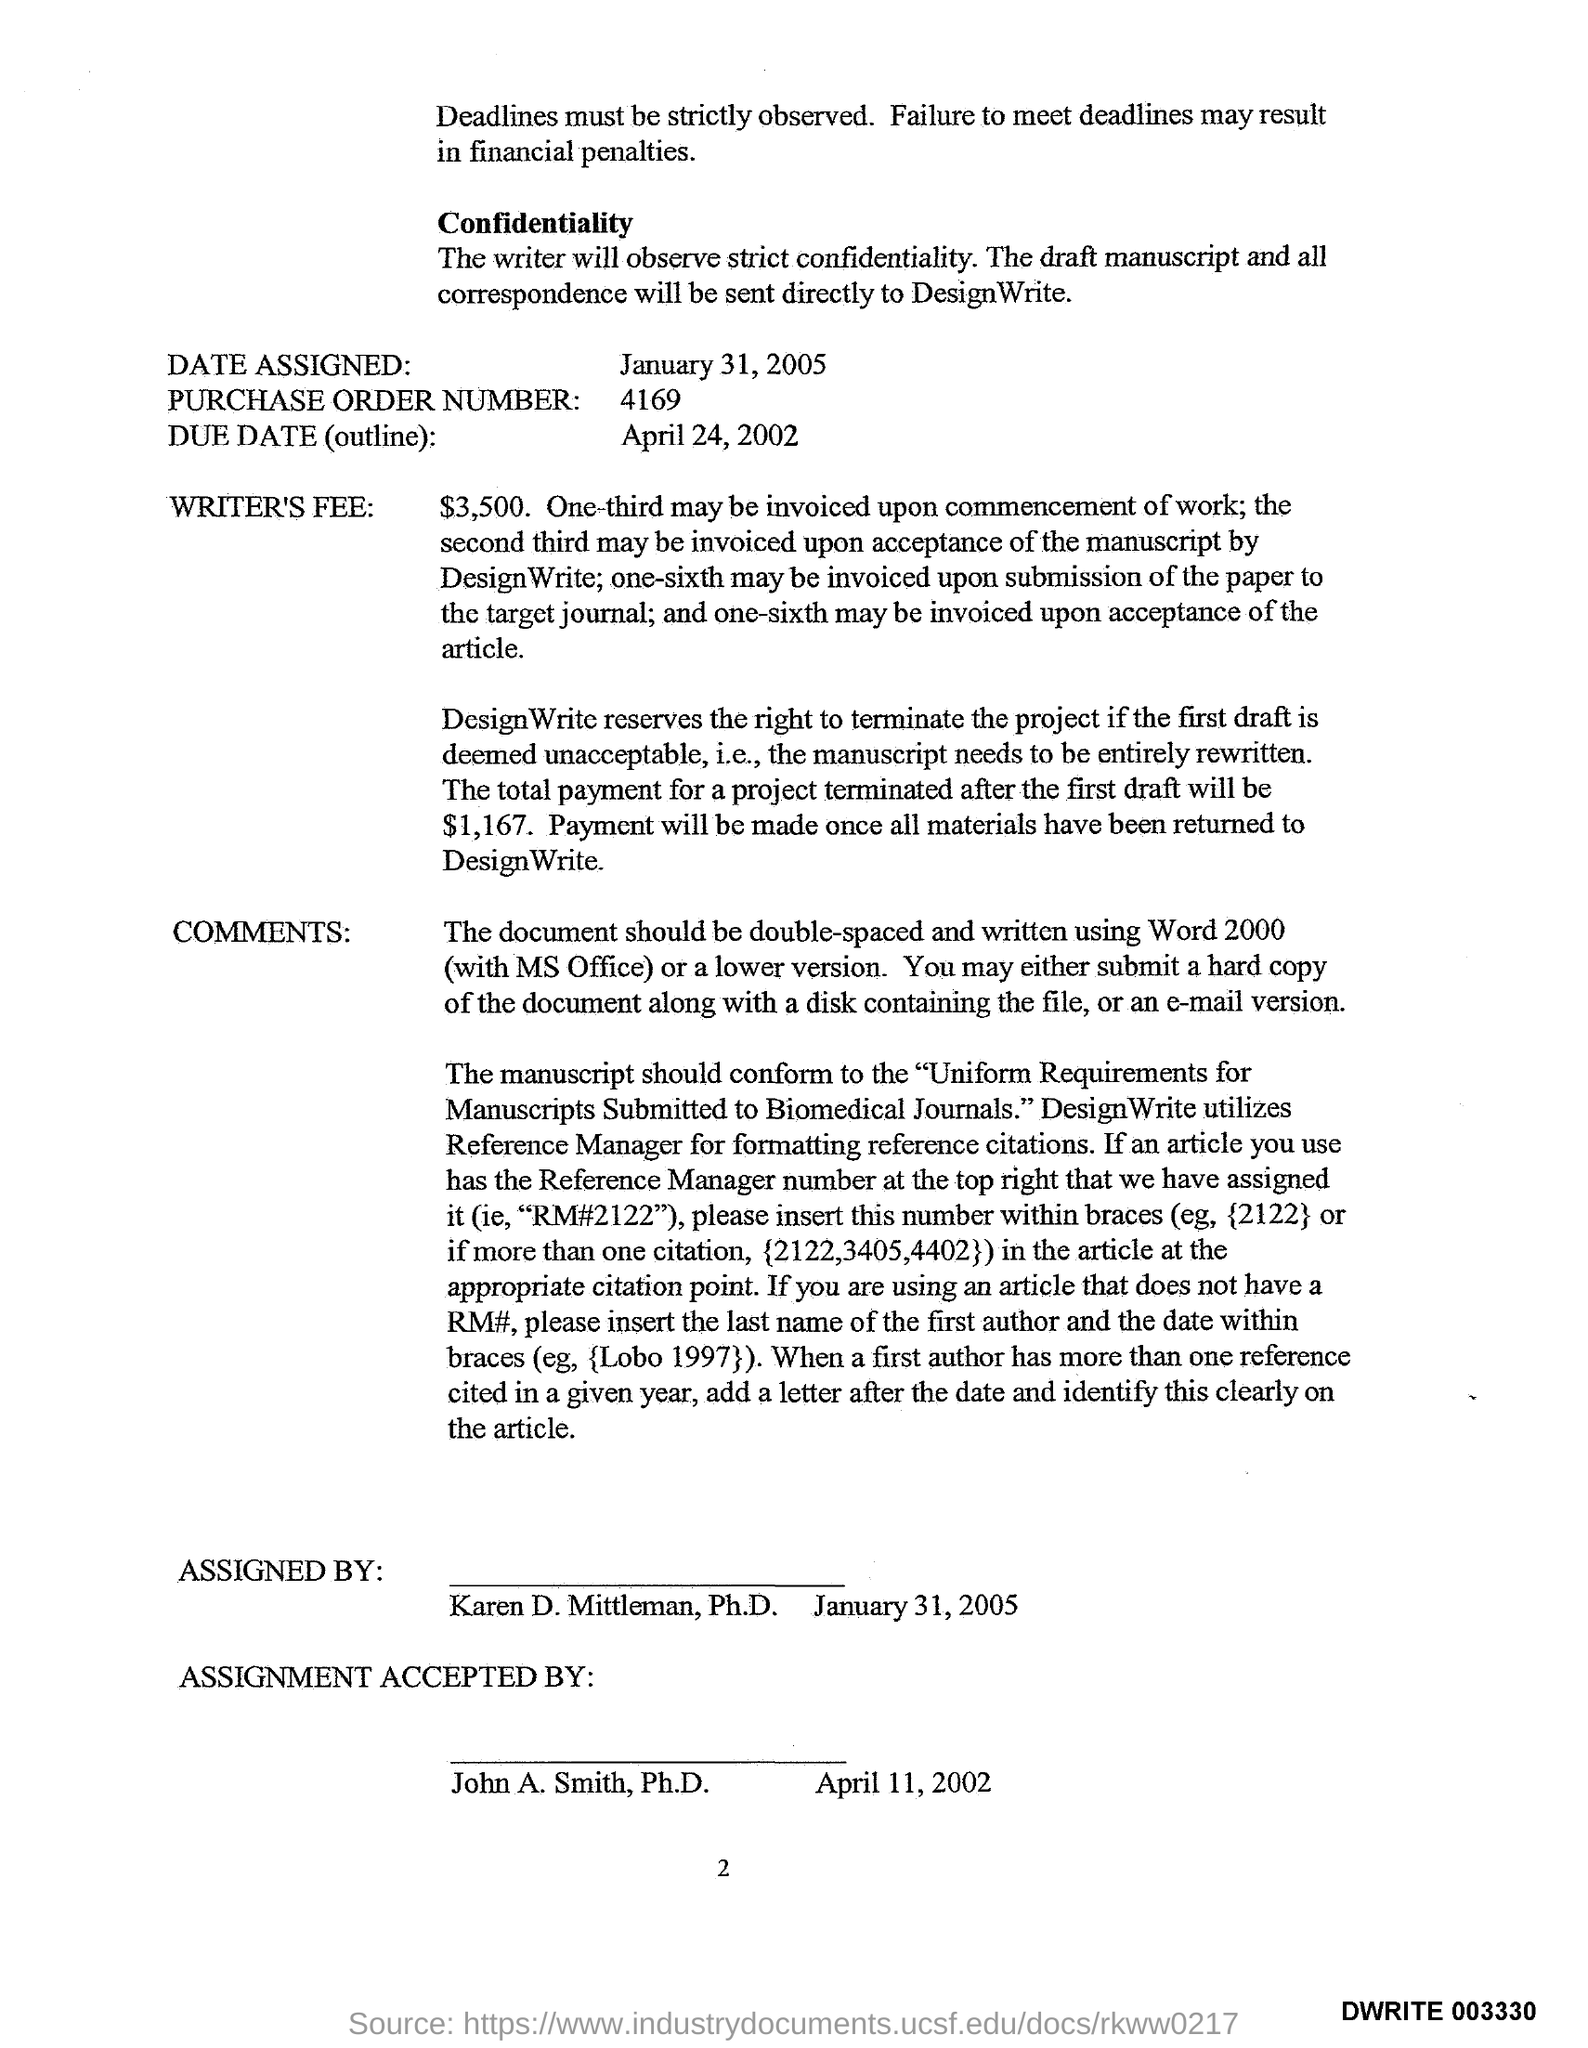What is the Date Assigned as per the document?
Your answer should be compact. January 31, 2005. What is the Purchase Order Number given in the document?
Your answer should be very brief. 4169. What is the Due Date(outline) mentioned in the document?
Provide a succinct answer. April 24, 2002. How much is the Writer's Fee?
Your response must be concise. $3,500. Who has accepted the assignment?
Keep it short and to the point. John A. Smith, Ph.D. When was the assignment accepted by John A. Smith, Ph.D.?
Ensure brevity in your answer.  April 11, 2002. 